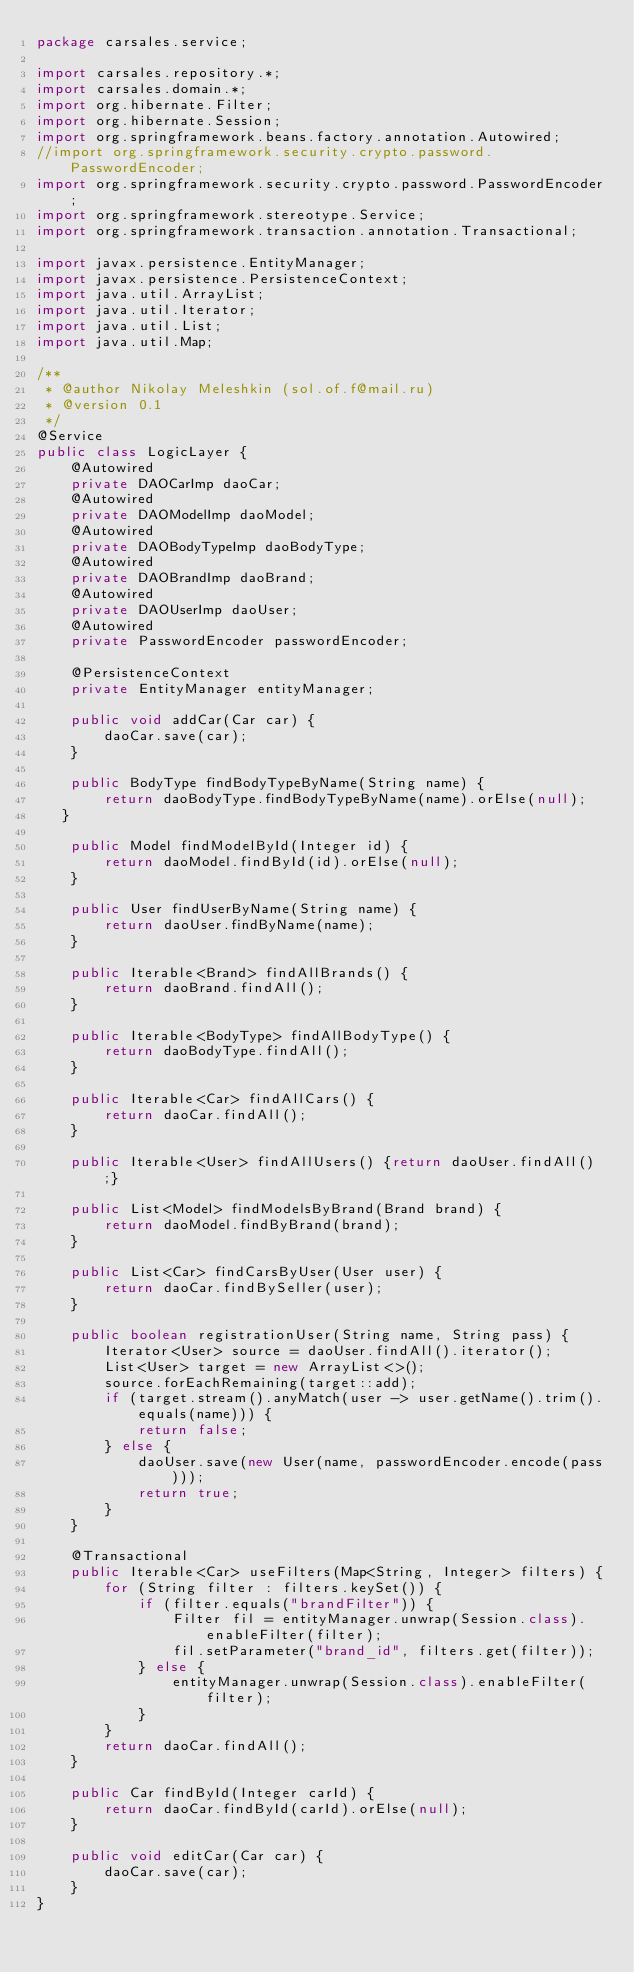Convert code to text. <code><loc_0><loc_0><loc_500><loc_500><_Java_>package carsales.service;

import carsales.repository.*;
import carsales.domain.*;
import org.hibernate.Filter;
import org.hibernate.Session;
import org.springframework.beans.factory.annotation.Autowired;
//import org.springframework.security.crypto.password.PasswordEncoder;
import org.springframework.security.crypto.password.PasswordEncoder;
import org.springframework.stereotype.Service;
import org.springframework.transaction.annotation.Transactional;

import javax.persistence.EntityManager;
import javax.persistence.PersistenceContext;
import java.util.ArrayList;
import java.util.Iterator;
import java.util.List;
import java.util.Map;

/**
 * @author Nikolay Meleshkin (sol.of.f@mail.ru)
 * @version 0.1
 */
@Service
public class LogicLayer {
    @Autowired
    private DAOCarImp daoCar;
    @Autowired
    private DAOModelImp daoModel;
    @Autowired
    private DAOBodyTypeImp daoBodyType;
    @Autowired
    private DAOBrandImp daoBrand;
    @Autowired
    private DAOUserImp daoUser;
    @Autowired
    private PasswordEncoder passwordEncoder;

    @PersistenceContext
    private EntityManager entityManager;

    public void addCar(Car car) {
        daoCar.save(car);
    }

    public BodyType findBodyTypeByName(String name) {
        return daoBodyType.findBodyTypeByName(name).orElse(null);
   }

    public Model findModelById(Integer id) {
        return daoModel.findById(id).orElse(null);
    }

    public User findUserByName(String name) {
        return daoUser.findByName(name);
    }

    public Iterable<Brand> findAllBrands() {
        return daoBrand.findAll();
    }

    public Iterable<BodyType> findAllBodyType() {
        return daoBodyType.findAll();
    }

    public Iterable<Car> findAllCars() {
        return daoCar.findAll();
    }

    public Iterable<User> findAllUsers() {return daoUser.findAll();}

    public List<Model> findModelsByBrand(Brand brand) {
        return daoModel.findByBrand(brand);
    }

    public List<Car> findCarsByUser(User user) {
        return daoCar.findBySeller(user);
    }

    public boolean registrationUser(String name, String pass) {
        Iterator<User> source = daoUser.findAll().iterator();
        List<User> target = new ArrayList<>();
        source.forEachRemaining(target::add);
        if (target.stream().anyMatch(user -> user.getName().trim().equals(name))) {
            return false;
        } else {
            daoUser.save(new User(name, passwordEncoder.encode(pass)));
            return true;
        }
    }

    @Transactional
    public Iterable<Car> useFilters(Map<String, Integer> filters) {
        for (String filter : filters.keySet()) {
            if (filter.equals("brandFilter")) {
                Filter fil = entityManager.unwrap(Session.class).enableFilter(filter);
                fil.setParameter("brand_id", filters.get(filter));
            } else {
                entityManager.unwrap(Session.class).enableFilter(filter);
            }
        }
        return daoCar.findAll();
    }

    public Car findById(Integer carId) {
        return daoCar.findById(carId).orElse(null);
    }

    public void editCar(Car car) {
        daoCar.save(car);
    }
}
</code> 